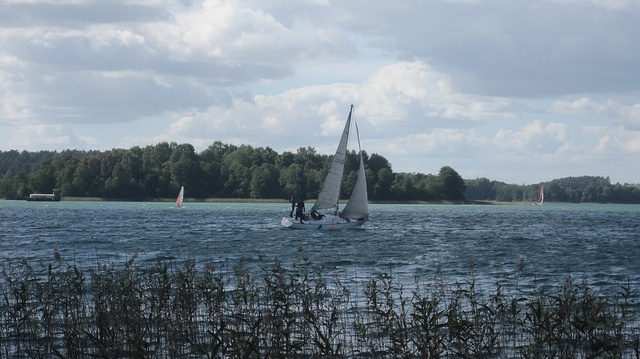Describe the objects in this image and their specific colors. I can see boat in lightgray, gray, black, and blue tones, people in lightgray, black, blue, and navy tones, boat in lightgray, darkgray, gray, and black tones, boat in lightgray, black, gray, and darkblue tones, and boat in lightgray, gray, darkgray, and brown tones in this image. 